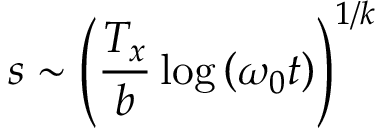Convert formula to latex. <formula><loc_0><loc_0><loc_500><loc_500>s \sim \left ( \frac { T _ { x } } { b } \log \left ( \omega _ { 0 } t \right ) \right ) ^ { 1 / k }</formula> 